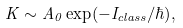Convert formula to latex. <formula><loc_0><loc_0><loc_500><loc_500>K \sim A _ { 0 } \exp ( - I _ { c l a s s } / \hbar { ) } ,</formula> 